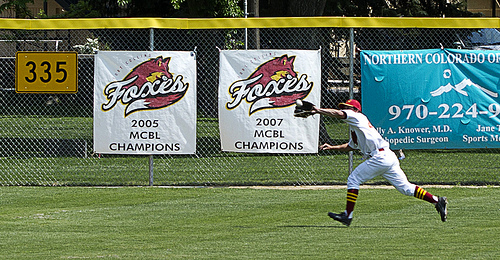<image>
Is the tree behind the net? Yes. From this viewpoint, the tree is positioned behind the net, with the net partially or fully occluding the tree. 